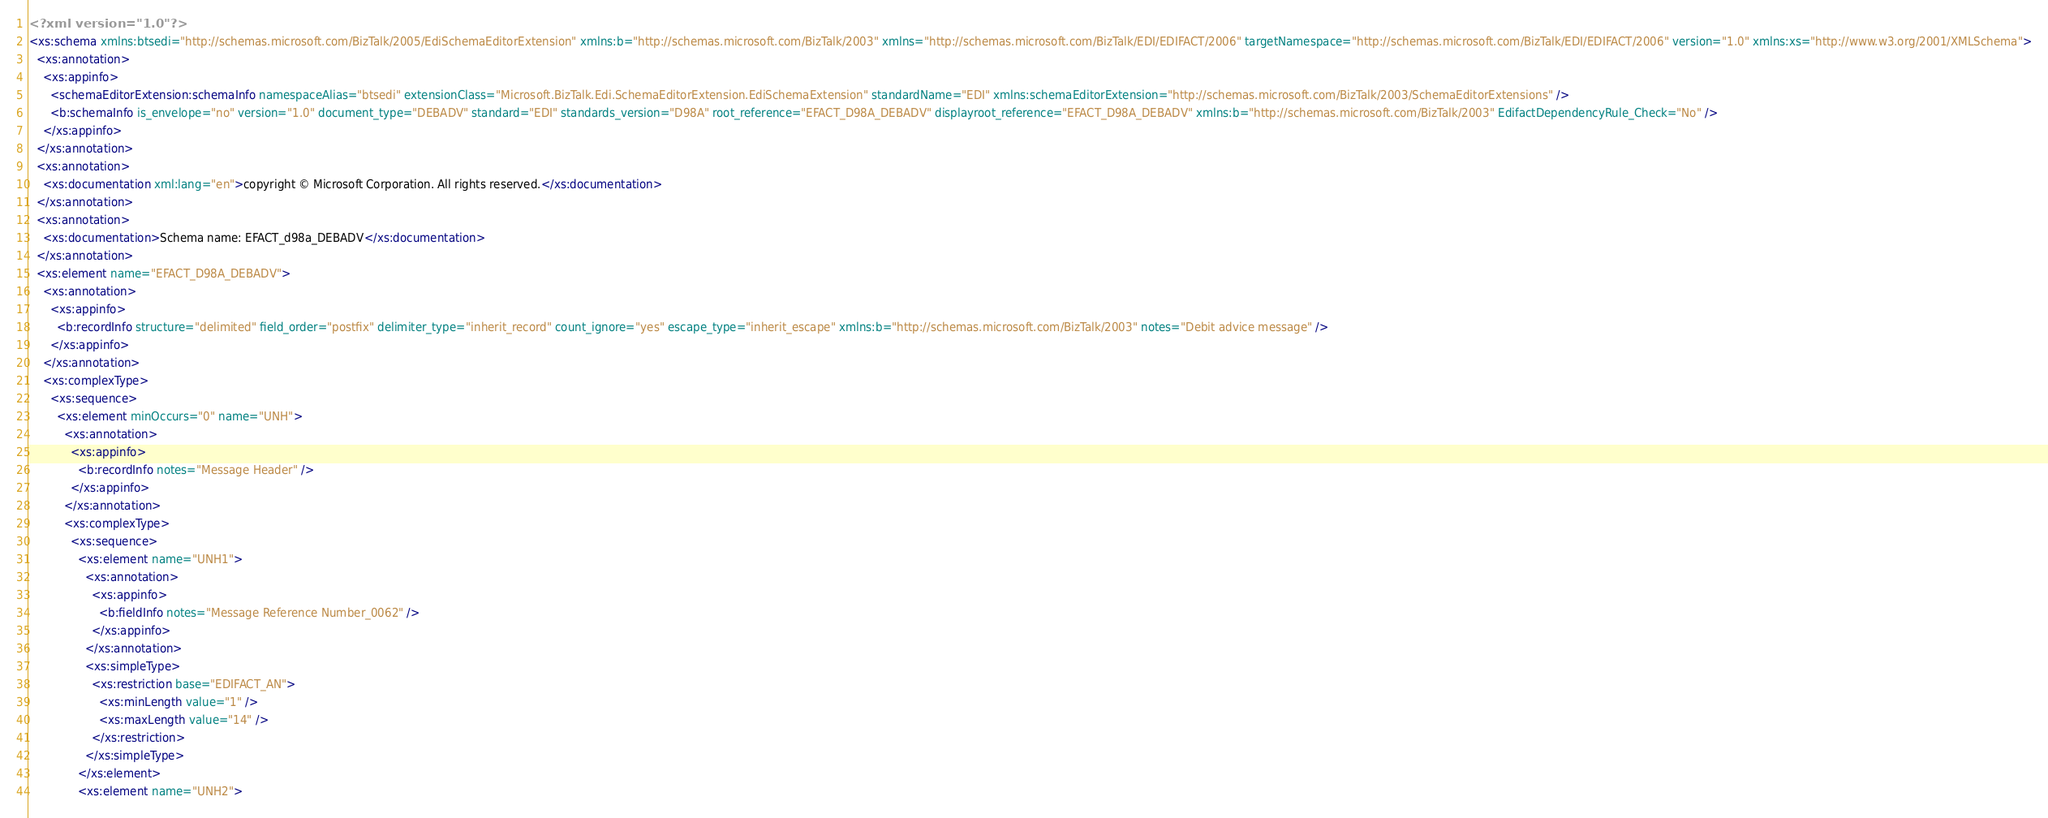Convert code to text. <code><loc_0><loc_0><loc_500><loc_500><_XML_><?xml version="1.0"?>
<xs:schema xmlns:btsedi="http://schemas.microsoft.com/BizTalk/2005/EdiSchemaEditorExtension" xmlns:b="http://schemas.microsoft.com/BizTalk/2003" xmlns="http://schemas.microsoft.com/BizTalk/EDI/EDIFACT/2006" targetNamespace="http://schemas.microsoft.com/BizTalk/EDI/EDIFACT/2006" version="1.0" xmlns:xs="http://www.w3.org/2001/XMLSchema">
  <xs:annotation>
    <xs:appinfo>
      <schemaEditorExtension:schemaInfo namespaceAlias="btsedi" extensionClass="Microsoft.BizTalk.Edi.SchemaEditorExtension.EdiSchemaExtension" standardName="EDI" xmlns:schemaEditorExtension="http://schemas.microsoft.com/BizTalk/2003/SchemaEditorExtensions" />
      <b:schemaInfo is_envelope="no" version="1.0" document_type="DEBADV" standard="EDI" standards_version="D98A" root_reference="EFACT_D98A_DEBADV" displayroot_reference="EFACT_D98A_DEBADV" xmlns:b="http://schemas.microsoft.com/BizTalk/2003" EdifactDependencyRule_Check="No" />
    </xs:appinfo>
  </xs:annotation>
  <xs:annotation>
    <xs:documentation xml:lang="en">copyright © Microsoft Corporation. All rights reserved.</xs:documentation>
  </xs:annotation>
  <xs:annotation>
    <xs:documentation>Schema name: EFACT_d98a_DEBADV</xs:documentation>
  </xs:annotation>
  <xs:element name="EFACT_D98A_DEBADV">
    <xs:annotation>
      <xs:appinfo>
        <b:recordInfo structure="delimited" field_order="postfix" delimiter_type="inherit_record" count_ignore="yes" escape_type="inherit_escape" xmlns:b="http://schemas.microsoft.com/BizTalk/2003" notes="Debit advice message" />
      </xs:appinfo>
    </xs:annotation>
    <xs:complexType>
      <xs:sequence>
        <xs:element minOccurs="0" name="UNH">
          <xs:annotation>
            <xs:appinfo>
              <b:recordInfo notes="Message Header" />
            </xs:appinfo>
          </xs:annotation>
          <xs:complexType>
            <xs:sequence>
              <xs:element name="UNH1">
                <xs:annotation>
                  <xs:appinfo>
                    <b:fieldInfo notes="Message Reference Number_0062" />
                  </xs:appinfo>
                </xs:annotation>
                <xs:simpleType>
                  <xs:restriction base="EDIFACT_AN">
                    <xs:minLength value="1" />
                    <xs:maxLength value="14" />
                  </xs:restriction>
                </xs:simpleType>
              </xs:element>
              <xs:element name="UNH2"></code> 